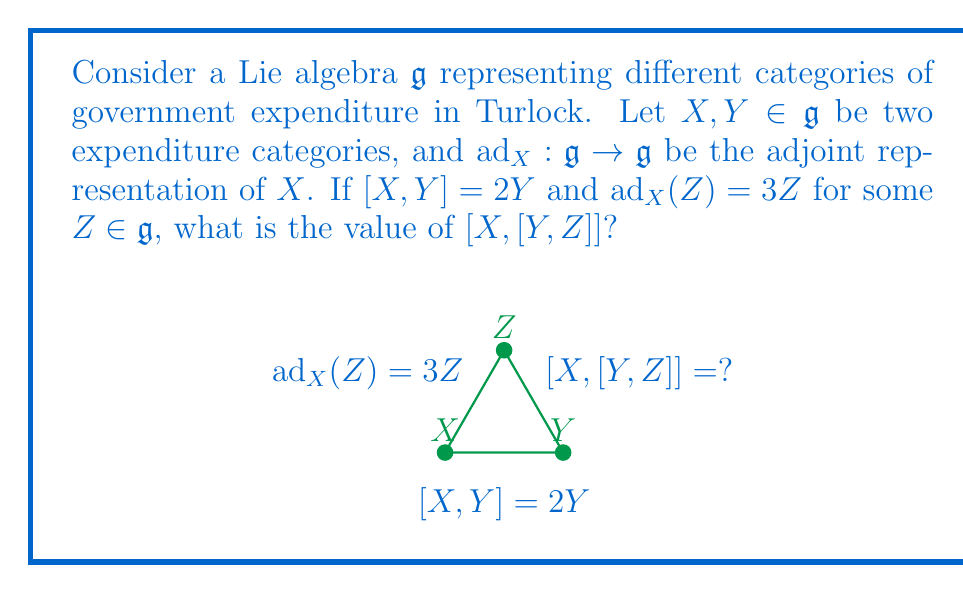Can you solve this math problem? Let's approach this step-by-step using the properties of Lie algebras and the adjoint representation:

1) First, recall the Jacobi identity for Lie algebras:
   $$[X,[Y,Z]] + [Y,[Z,X]] + [Z,[X,Y]] = 0$$

2) We're given that $[X,Y] = 2Y$. Let's substitute this into the Jacobi identity:
   $$[X,[Y,Z]] + [Y,[Z,X]] + [Z,2Y] = 0$$

3) Now, let's focus on $\text{ad}_X(Z) = 3Z$. By definition of the adjoint representation, this means:
   $$[X,Z] = 3Z$$

4) Substituting this into our equation from step 2:
   $$[X,[Y,Z]] + [Y,-3Z] + [Z,2Y] = 0$$

5) Using the linearity of the Lie bracket:
   $$[X,[Y,Z]] - 3[Y,Z] + 2[Z,Y] = 0$$

6) Note that $[Z,Y] = -[Y,Z]$ (antisymmetry of the Lie bracket). Substituting:
   $$[X,[Y,Z]] - 3[Y,Z] - 2[Y,Z] = 0$$

7) Simplifying:
   $$[X,[Y,Z]] = 5[Y,Z]$$

8) Therefore, $[X,[Y,Z]] = 5[Y,Z] = \text{ad}_X([Y,Z])$

This result shows that $[Y,Z]$ is an eigenvector of $\text{ad}_X$ with eigenvalue 5.
Answer: $5[Y,Z]$ 